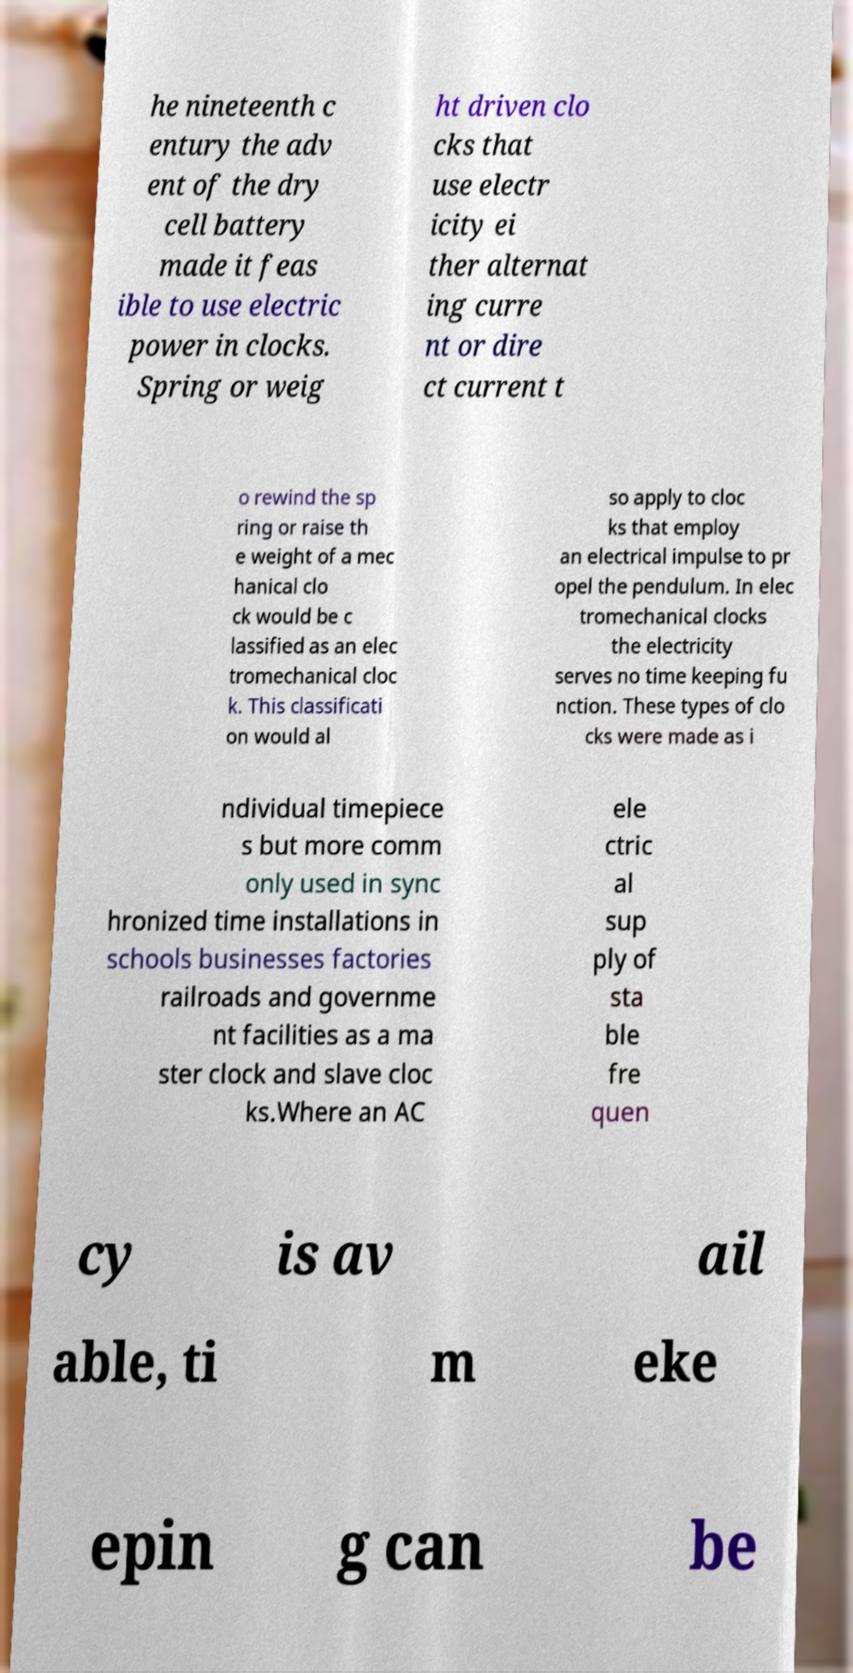I need the written content from this picture converted into text. Can you do that? he nineteenth c entury the adv ent of the dry cell battery made it feas ible to use electric power in clocks. Spring or weig ht driven clo cks that use electr icity ei ther alternat ing curre nt or dire ct current t o rewind the sp ring or raise th e weight of a mec hanical clo ck would be c lassified as an elec tromechanical cloc k. This classificati on would al so apply to cloc ks that employ an electrical impulse to pr opel the pendulum. In elec tromechanical clocks the electricity serves no time keeping fu nction. These types of clo cks were made as i ndividual timepiece s but more comm only used in sync hronized time installations in schools businesses factories railroads and governme nt facilities as a ma ster clock and slave cloc ks.Where an AC ele ctric al sup ply of sta ble fre quen cy is av ail able, ti m eke epin g can be 